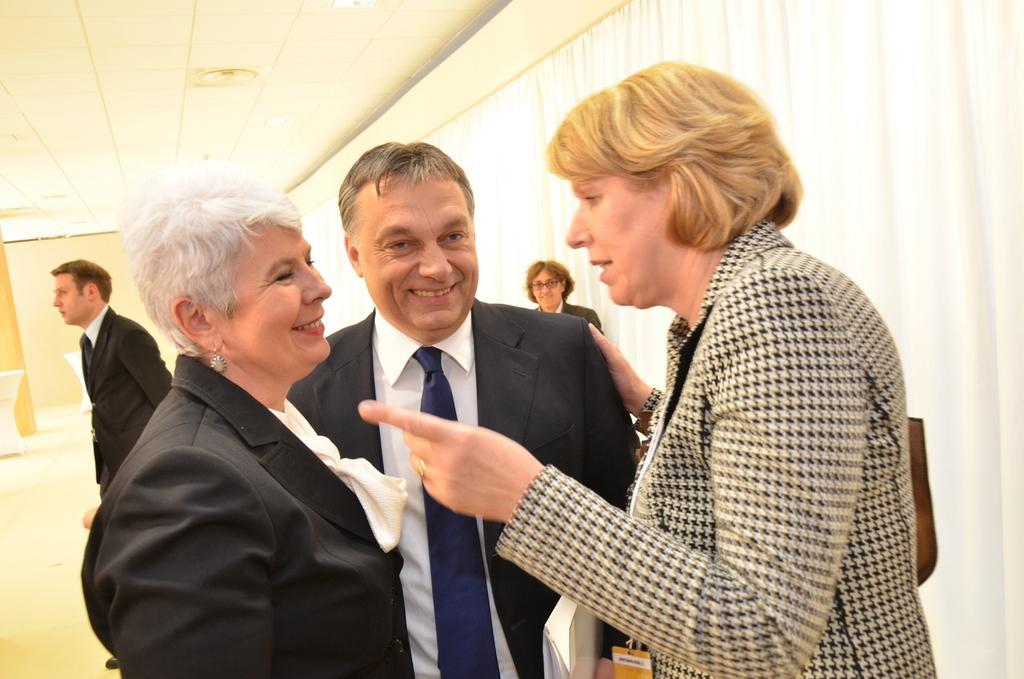In one or two sentences, can you explain what this image depicts? In this picture there is a person with black and white jacket is standing and talking. There are two persons standing and smiling. At the back there are group of people. On the right side of the image there is a curtain. On the left side of the image there are tables. At the top there are lights. 